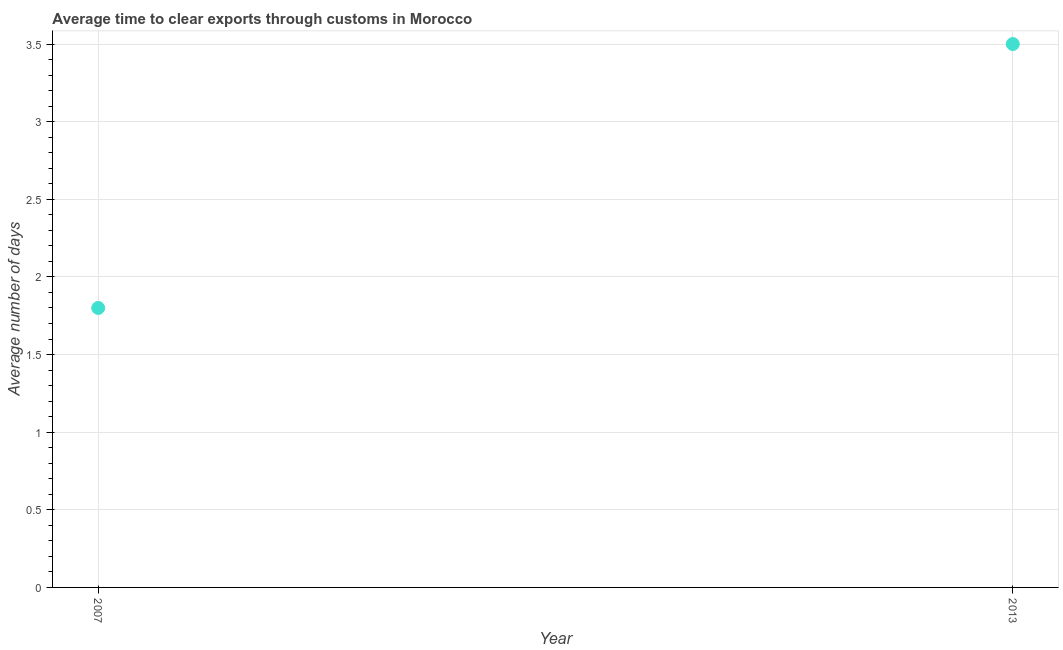What is the time to clear exports through customs in 2007?
Your answer should be very brief. 1.8. Across all years, what is the minimum time to clear exports through customs?
Your answer should be compact. 1.8. What is the sum of the time to clear exports through customs?
Offer a very short reply. 5.3. What is the average time to clear exports through customs per year?
Make the answer very short. 2.65. What is the median time to clear exports through customs?
Make the answer very short. 2.65. In how many years, is the time to clear exports through customs greater than 1.2 days?
Offer a terse response. 2. Do a majority of the years between 2013 and 2007 (inclusive) have time to clear exports through customs greater than 2.8 days?
Provide a short and direct response. No. What is the ratio of the time to clear exports through customs in 2007 to that in 2013?
Give a very brief answer. 0.51. What is the difference between two consecutive major ticks on the Y-axis?
Provide a short and direct response. 0.5. Are the values on the major ticks of Y-axis written in scientific E-notation?
Ensure brevity in your answer.  No. Does the graph contain grids?
Your response must be concise. Yes. What is the title of the graph?
Provide a short and direct response. Average time to clear exports through customs in Morocco. What is the label or title of the X-axis?
Give a very brief answer. Year. What is the label or title of the Y-axis?
Make the answer very short. Average number of days. What is the Average number of days in 2013?
Ensure brevity in your answer.  3.5. What is the ratio of the Average number of days in 2007 to that in 2013?
Ensure brevity in your answer.  0.51. 